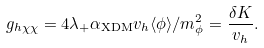<formula> <loc_0><loc_0><loc_500><loc_500>g _ { h \chi \chi } = 4 \lambda _ { + } \alpha _ { \text {XDM} } v _ { h } \langle \phi \rangle / m _ { \phi } ^ { 2 } = \frac { \delta K } { v _ { h } } .</formula> 